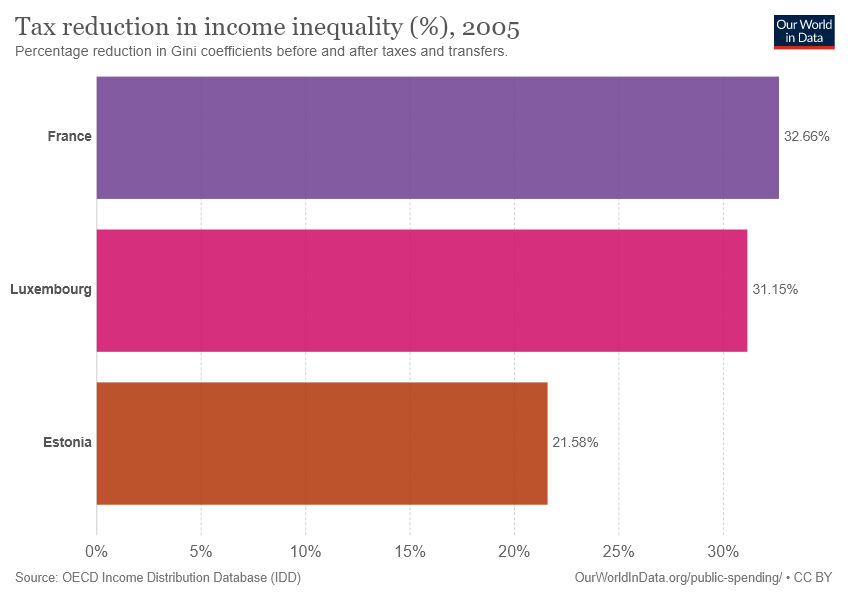List a handful of essential elements in this visual. The value difference between Estonia and France is 11.08. The value of the brown bar is 21.58. 